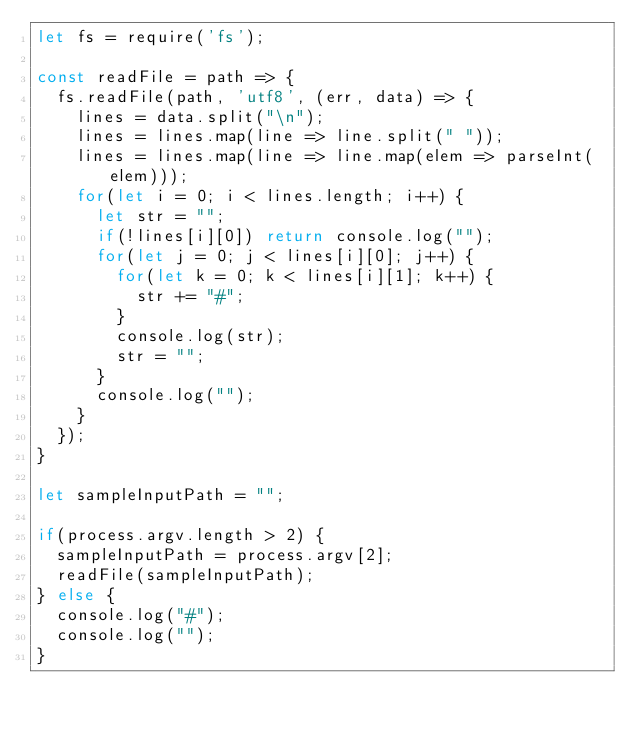Convert code to text. <code><loc_0><loc_0><loc_500><loc_500><_JavaScript_>let fs = require('fs');

const readFile = path => {
  fs.readFile(path, 'utf8', (err, data) => {
    lines = data.split("\n");
    lines = lines.map(line => line.split(" "));
    lines = lines.map(line => line.map(elem => parseInt(elem)));
    for(let i = 0; i < lines.length; i++) {
      let str = "";
      if(!lines[i][0]) return console.log("");
      for(let j = 0; j < lines[i][0]; j++) {
        for(let k = 0; k < lines[i][1]; k++) {
          str += "#";
        }
        console.log(str);
        str = "";
      }
      console.log("");
    }
  });
}

let sampleInputPath = "";

if(process.argv.length > 2) {
  sampleInputPath = process.argv[2];
  readFile(sampleInputPath);
} else {
  console.log("#");
  console.log("");
}

</code> 